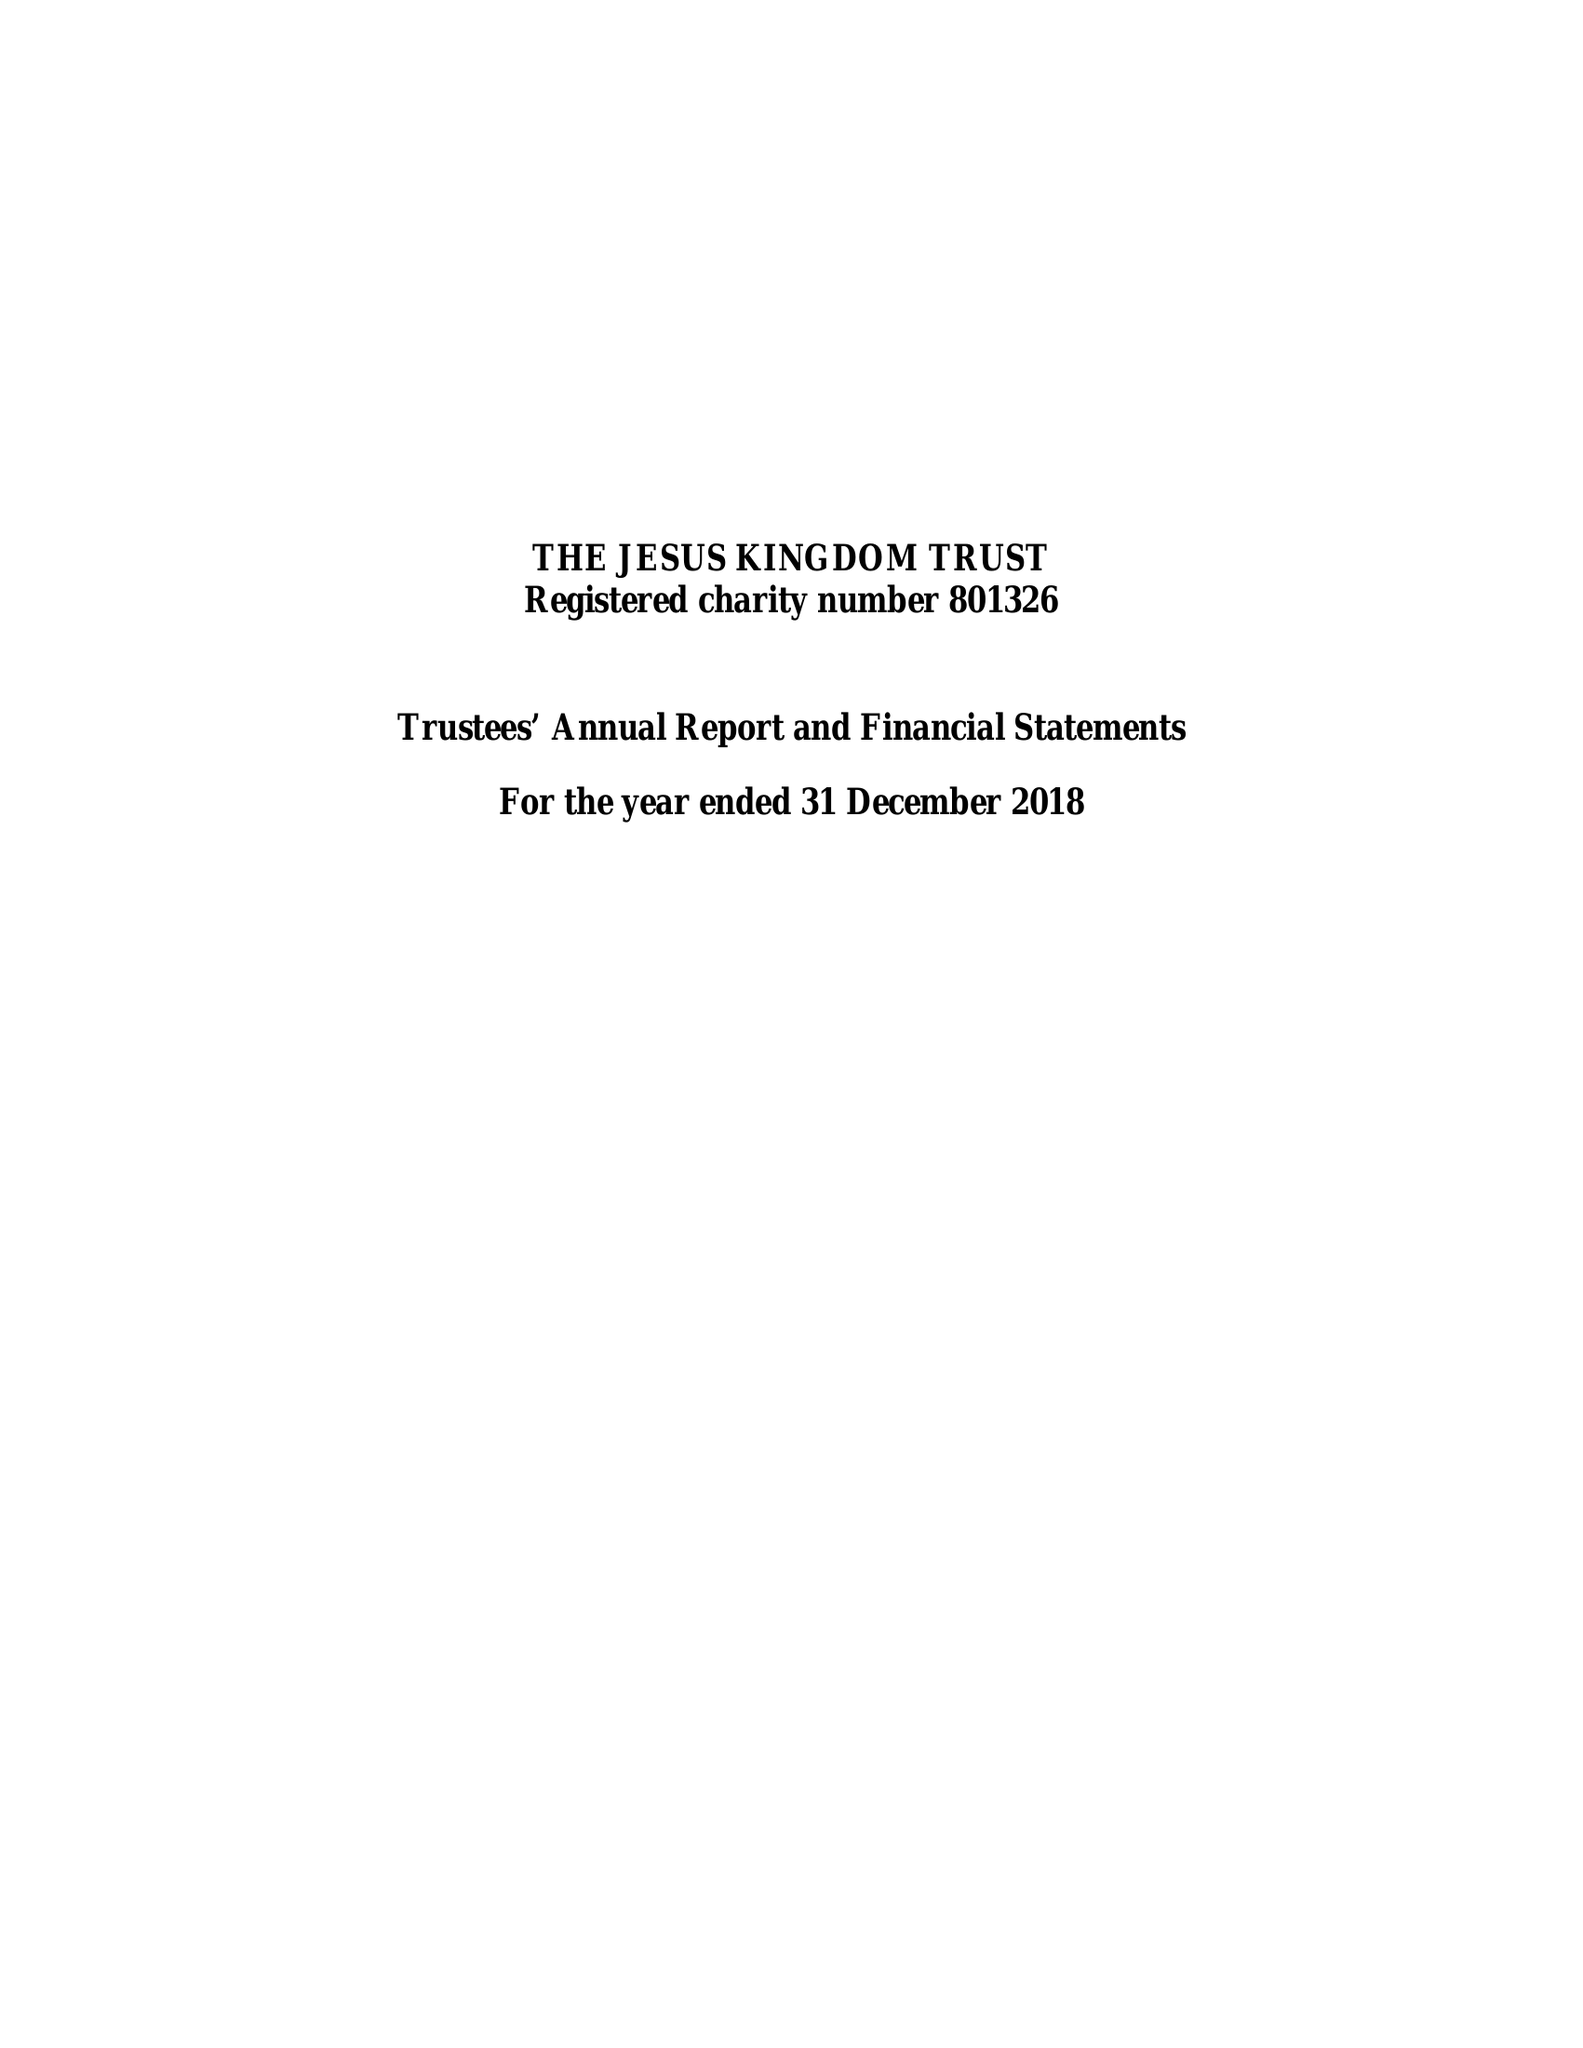What is the value for the address__street_line?
Answer the question using a single word or phrase. 913 HIGH ROAD 